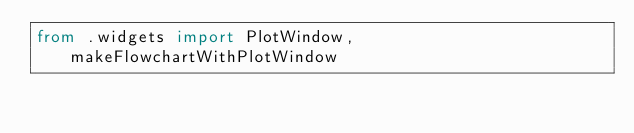<code> <loc_0><loc_0><loc_500><loc_500><_Python_>from .widgets import PlotWindow, makeFlowchartWithPlotWindow
</code> 